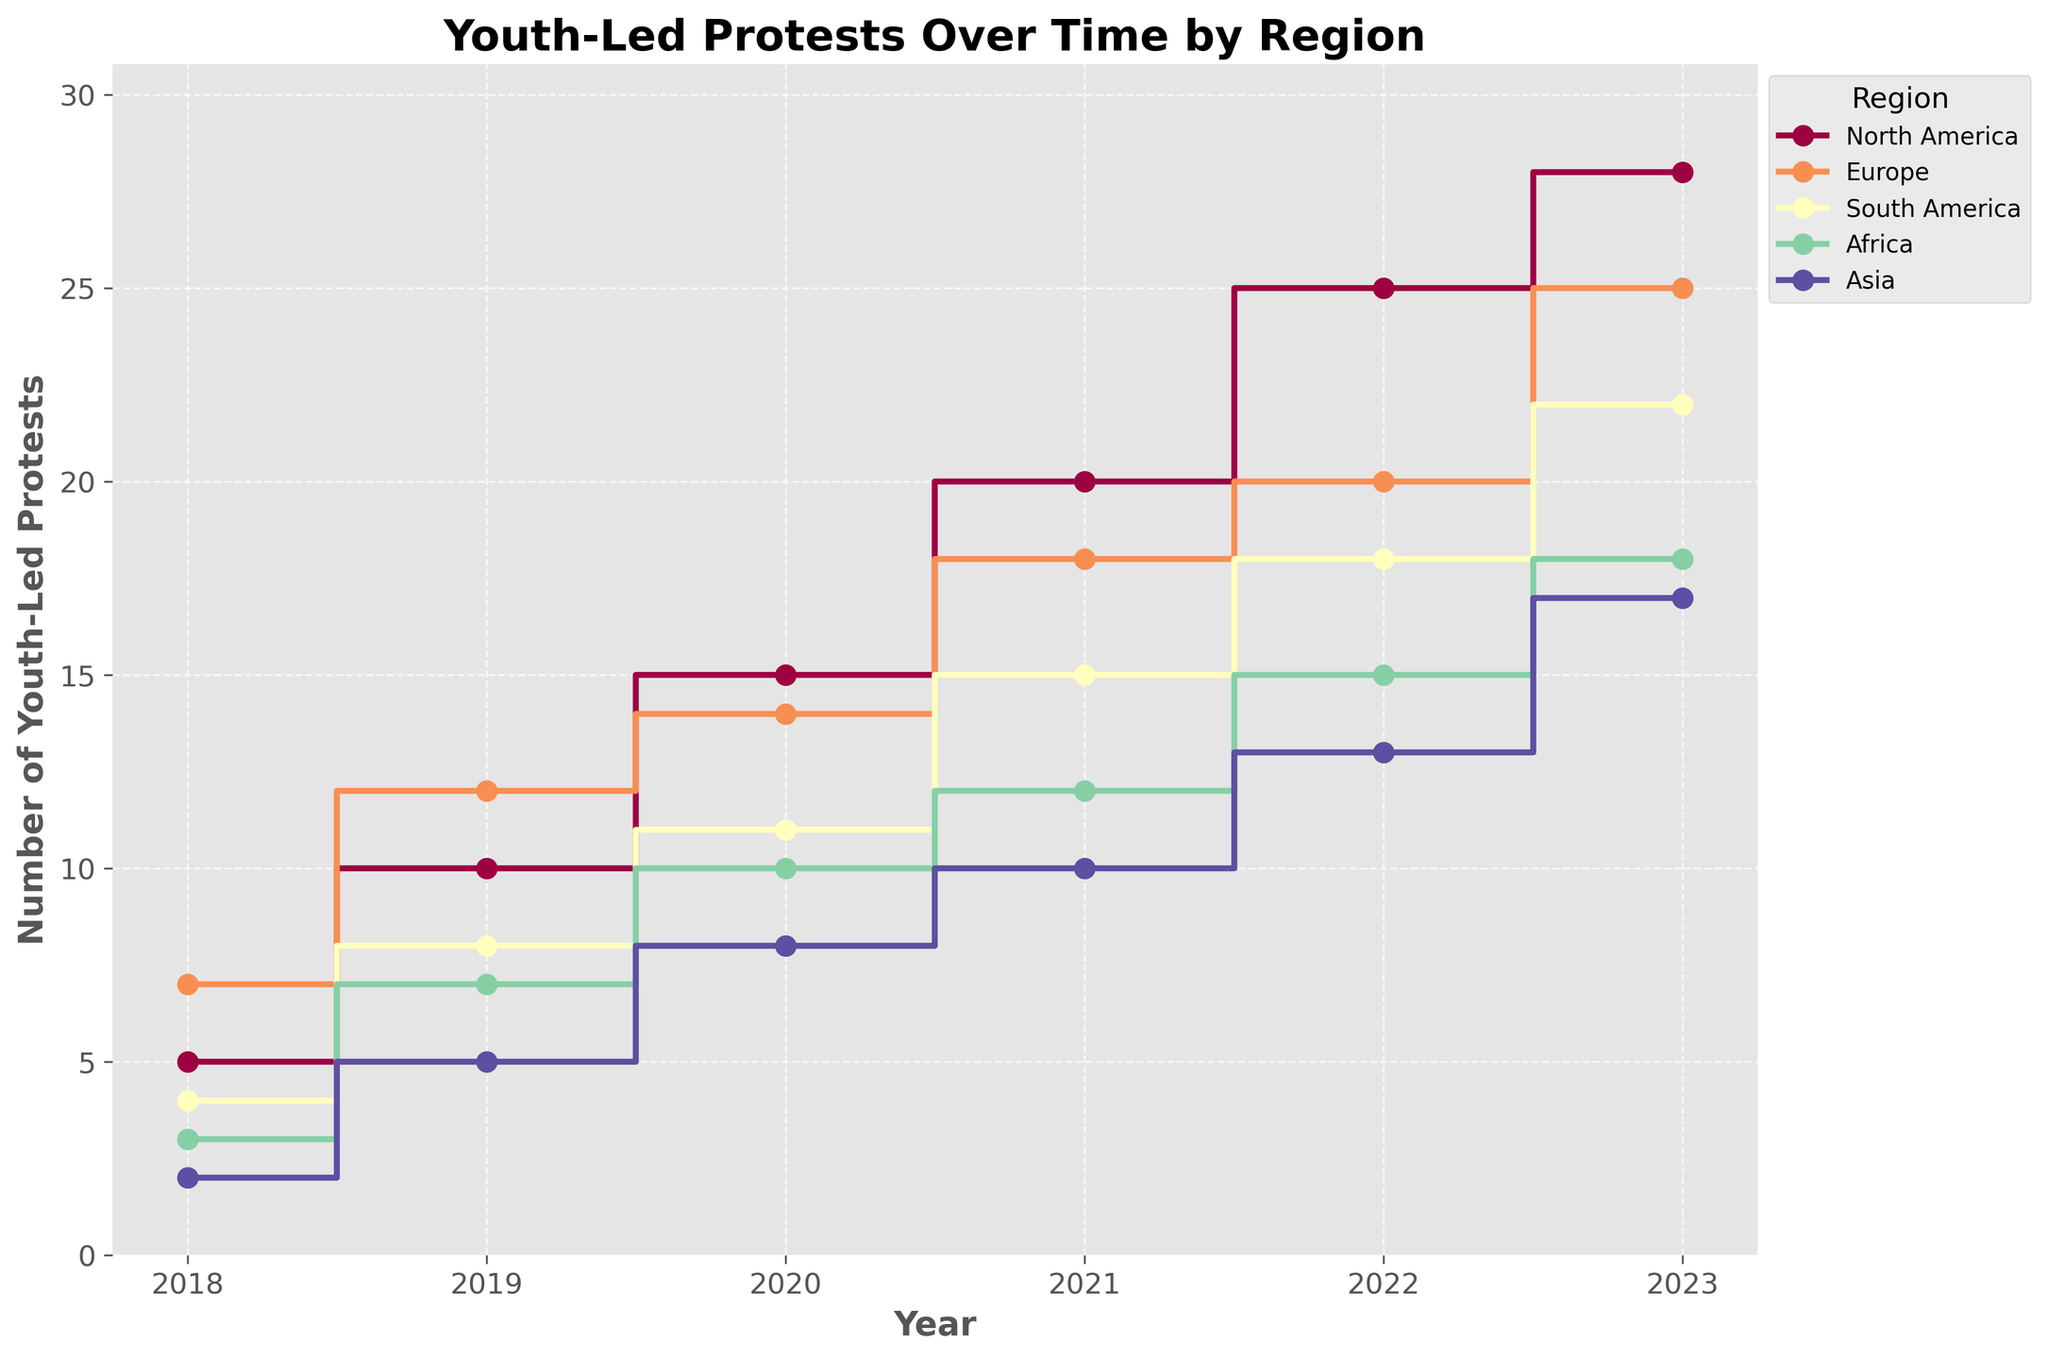What is the title of the plot? Look at the top of the figure where the title is typically placed. It provides a summary of what the plot represents.
Answer: Youth-Led Protests Over Time by Region Which region had the highest number of protests in 2023? Locate the data points corresponding to the year 2023 and compare the heights of the steps for each region.
Answer: North America How many protests were held in Europe in 2020? Follow the step plot line for Europe to the year 2020 and note the corresponding value.
Answer: 14 What is the overall trend of the number of youth-led protests in South America from 2018 to 2023? Observe the shape of the step plot for South America, noting whether it generally ascends, descends, or stays constant over the years.
Answer: Increasing How does the number of youth-led protests change in Africa from 2018 to 2021? Identify the data points for Africa in the years 2018 and 2021 and compute the difference.
Answer: Increased by 9 (from 3 to 12) By how much did the number of youth-led protests in Asia increase from 2018 to 2023? Locate the data points for Asia in the years 2018 and 2023 and subtract the former from the latter.
Answer: Increase by 15 In which year did North America see the least number of youth-led protests? Identify the year with the lowest step height for North America.
Answer: 2018 Compare the number of protests in Europe and Asia in 2023. Which region had more and by how much? Identify the height of steps for both regions in 2023 and subtract the lower from the higher.
Answer: Europe by 8 (25 - 17) Which two regions had the largest difference in the number of protests in 2022, and what was the difference? For the year 2022, find the regions with the highest and lowest values and compute the difference.
Answer: North America and Asia with a difference of 12 (25 - 13) Are there any regions where the number of protests remained constant over the years? Examine the step plots for all regions to see if any remain flat without any increase or decrease over the timeline.
Answer: No 